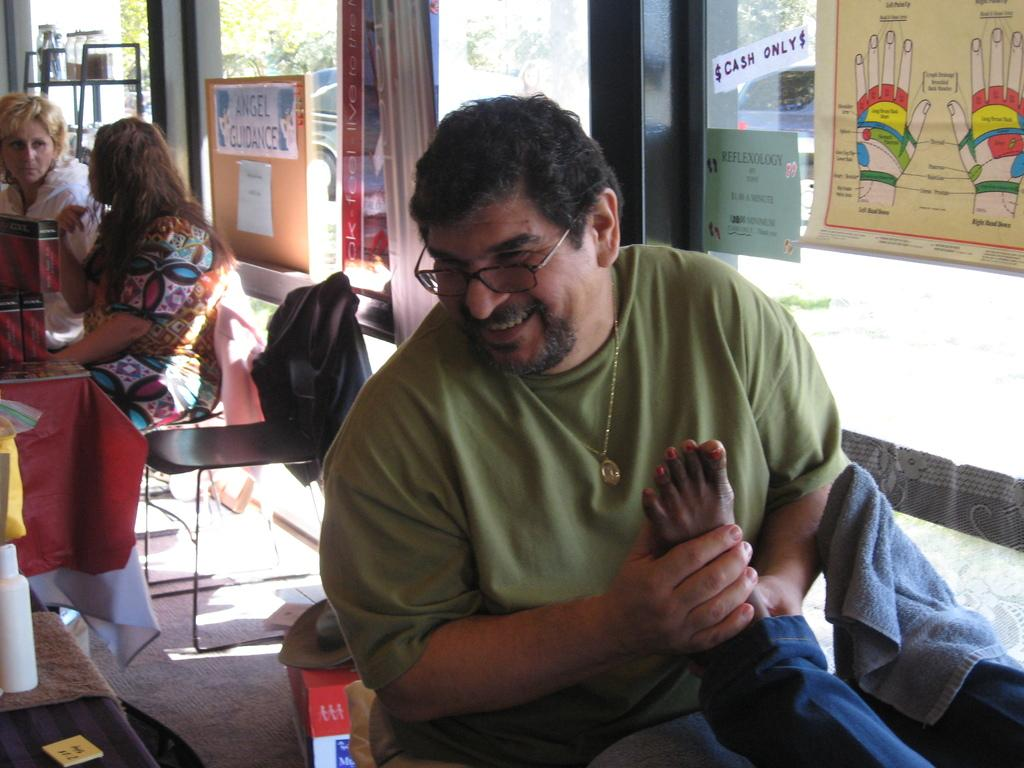How many people are in the image? There are persons in the image, but the exact number cannot be determined from the provided facts. What type of furniture is present in the image? There are chairs in the image. What can be seen on the boards in the image? There are drawings on the boards in the image. What is the primary mode of transportation in the image? There is a vehicle in the image, which suggests it might be a primary mode of transportation. What is the surface on which the vehicle is traveling? There is a road in the image, which is the surface on which the vehicle is traveling. What type of containers are present in the image? There are jars in the image. What type of surface is present in the image for placing objects? There is a table in the image, which is a surface for placing objects. What type of openings are present in the image? There are windows in the image. What type of natural vegetation is present in the image? There are trees in the image. What year is depicted in the image? The provided facts do not mention any specific year or time period, so it cannot be determined from the image. Can you see a rifle in the image? There is no mention of a rifle in the provided facts, so it cannot be determined if one is present in the image. 